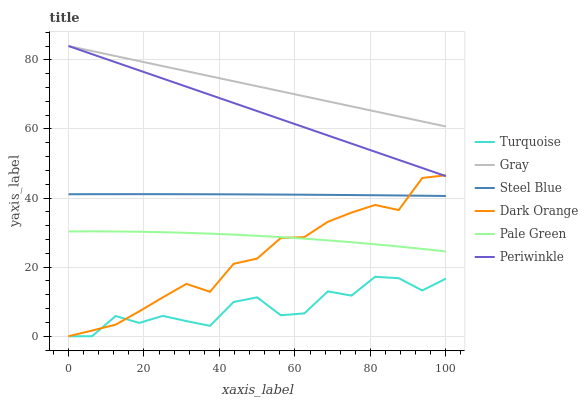Does Turquoise have the minimum area under the curve?
Answer yes or no. Yes. Does Gray have the maximum area under the curve?
Answer yes or no. Yes. Does Dark Orange have the minimum area under the curve?
Answer yes or no. No. Does Dark Orange have the maximum area under the curve?
Answer yes or no. No. Is Gray the smoothest?
Answer yes or no. Yes. Is Turquoise the roughest?
Answer yes or no. Yes. Is Dark Orange the smoothest?
Answer yes or no. No. Is Dark Orange the roughest?
Answer yes or no. No. Does Turquoise have the lowest value?
Answer yes or no. Yes. Does Steel Blue have the lowest value?
Answer yes or no. No. Does Periwinkle have the highest value?
Answer yes or no. Yes. Does Dark Orange have the highest value?
Answer yes or no. No. Is Pale Green less than Periwinkle?
Answer yes or no. Yes. Is Pale Green greater than Turquoise?
Answer yes or no. Yes. Does Dark Orange intersect Periwinkle?
Answer yes or no. Yes. Is Dark Orange less than Periwinkle?
Answer yes or no. No. Is Dark Orange greater than Periwinkle?
Answer yes or no. No. Does Pale Green intersect Periwinkle?
Answer yes or no. No. 